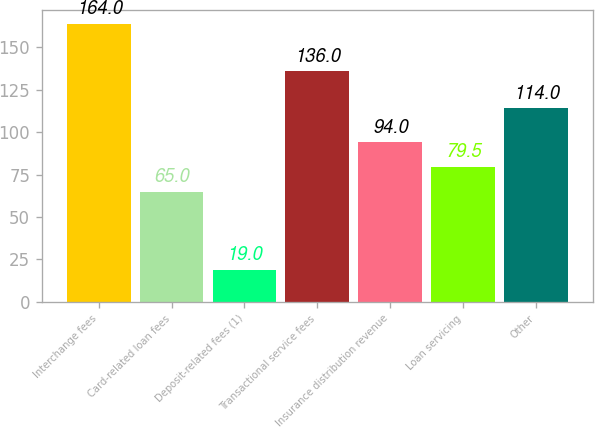Convert chart to OTSL. <chart><loc_0><loc_0><loc_500><loc_500><bar_chart><fcel>Interchange fees<fcel>Card-related loan fees<fcel>Deposit-related fees (1)<fcel>Transactional service fees<fcel>Insurance distribution revenue<fcel>Loan servicing<fcel>Other<nl><fcel>164<fcel>65<fcel>19<fcel>136<fcel>94<fcel>79.5<fcel>114<nl></chart> 